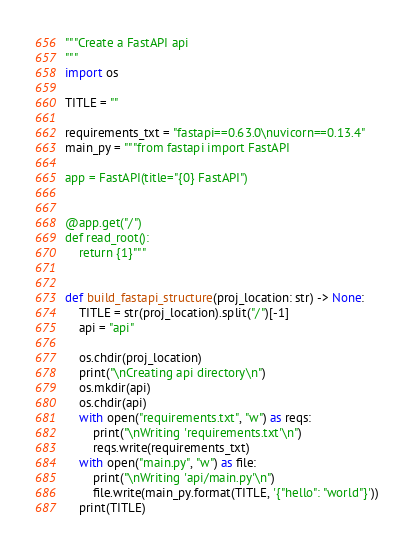<code> <loc_0><loc_0><loc_500><loc_500><_Python_>"""Create a FastAPI api
"""
import os

TITLE = ""

requirements_txt = "fastapi==0.63.0\nuvicorn==0.13.4"
main_py = """from fastapi import FastAPI

app = FastAPI(title="{0} FastAPI")


@app.get("/")
def read_root():
    return {1}"""


def build_fastapi_structure(proj_location: str) -> None:
    TITLE = str(proj_location).split("/")[-1]
    api = "api"

    os.chdir(proj_location)
    print("\nCreating api directory\n")
    os.mkdir(api)
    os.chdir(api)
    with open("requirements.txt", "w") as reqs:
        print("\nWriting 'requirements.txt'\n")
        reqs.write(requirements_txt)
    with open("main.py", "w") as file:
        print("\nWriting 'api/main.py'\n")
        file.write(main_py.format(TITLE, '{"hello": "world"}'))
    print(TITLE)
</code> 